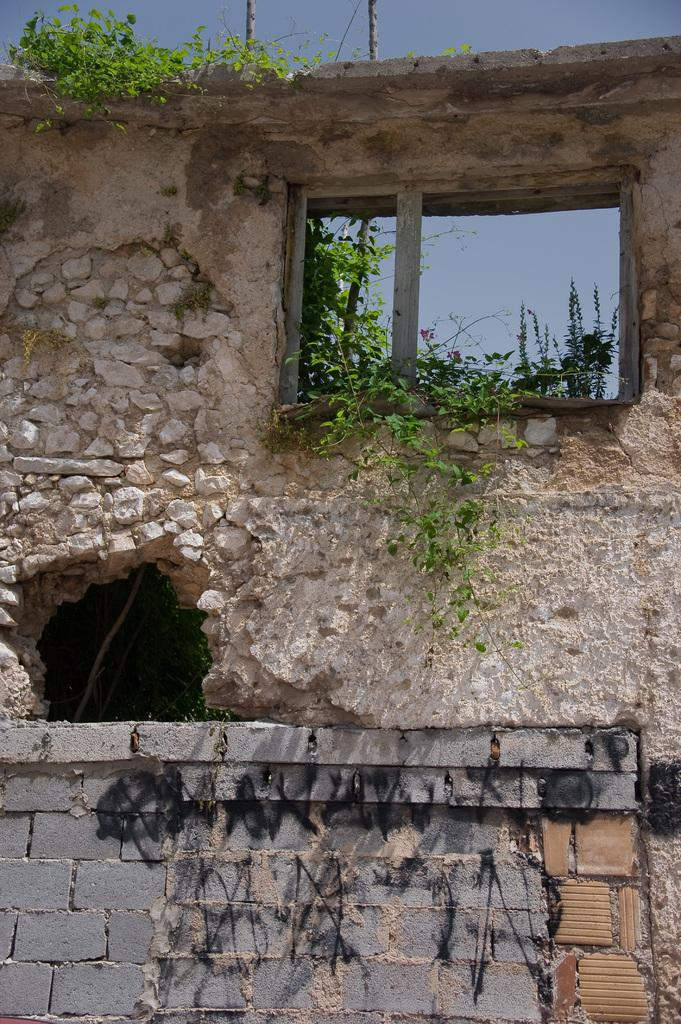What is located at the front of the image? There is a wall in the front of the image. What can be seen in the middle of the image? There are plants in the middle of the image. What is visible in the background of the image? The sky is visible in the image. What type of vegetation is present at the top of the image? Leaves are present at the top of the image. How many balloons are tied to the chair in the image? There are no balloons or chairs present in the image. What is the health status of the plants in the image? The provided facts do not give any information about the health status of the plants; we can only observe their presence in the image. 